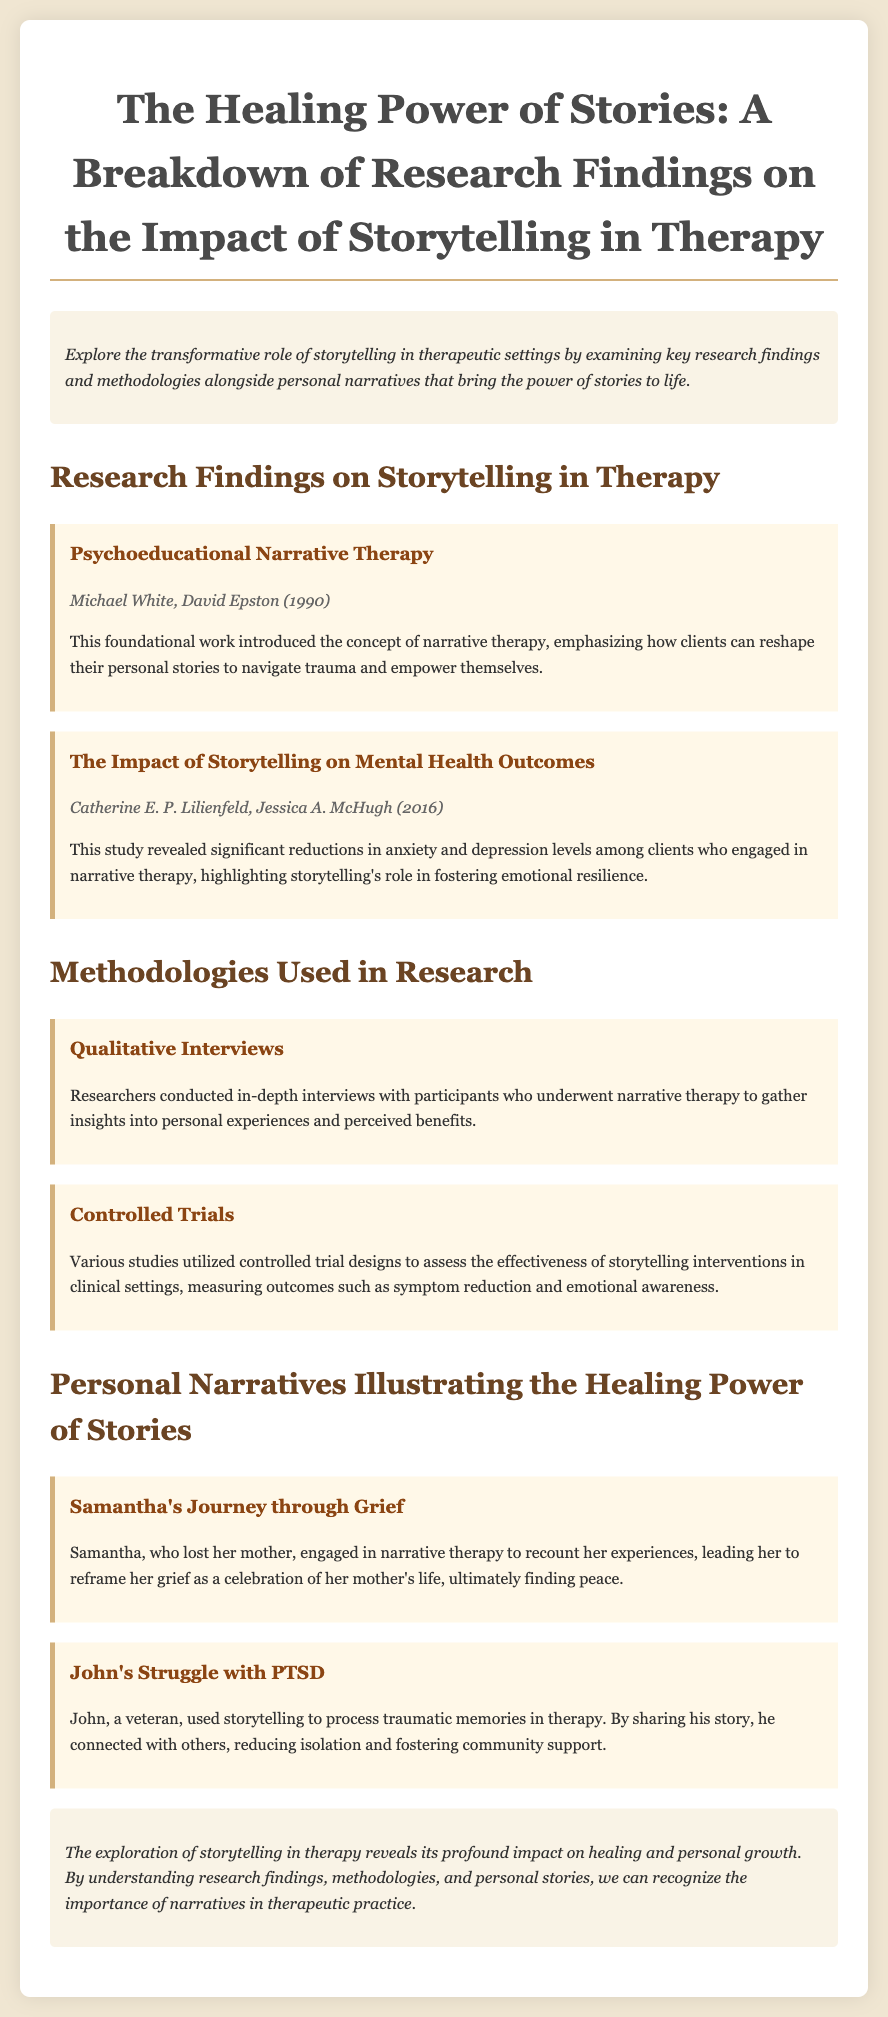What is the title of the document? The title is presented at the top of the document, indicating the main theme of the content.
Answer: The Healing Power of Stories: A Breakdown of Research Findings on the Impact of Storytelling in Therapy Who are the authors of the foundational work on narrative therapy? The document explicitly lists the authors of this influential study within the "Research Findings" section.
Answer: Michael White, David Epston What year was the study on the impact of storytelling published? The year is included next to the authors in the research findings section.
Answer: 2016 What therapeutic approach is Samantha using? The document describes the type of therapy Samantha participated in as a part of her healing journey.
Answer: Narrative therapy What was one outcome of John sharing his story? The document notes a specific effect of John's storytelling on his emotional state and social connections.
Answer: Reducing isolation How is the effectiveness of storytelling interventions assessed in research? This is mentioned in the "Methodologies Used in Research" section, describing the approach taken to evaluate storytelling in therapy.
Answer: Controlled trials What is the main theme explored in the conclusion? The conclusion summarizes the key message about the overall impact of storytelling in therapeutic practices.
Answer: Healing and personal growth Which personal narrative exemplifies grief? This is stated in the section detailing personal stories that illustrate the healing effects of storytelling in therapy.
Answer: Samantha's Journey through Grief What methodological approach involves participant interviews? The document outlines this approach as one of the methodologies employed in research on narrative therapy.
Answer: Qualitative interviews 